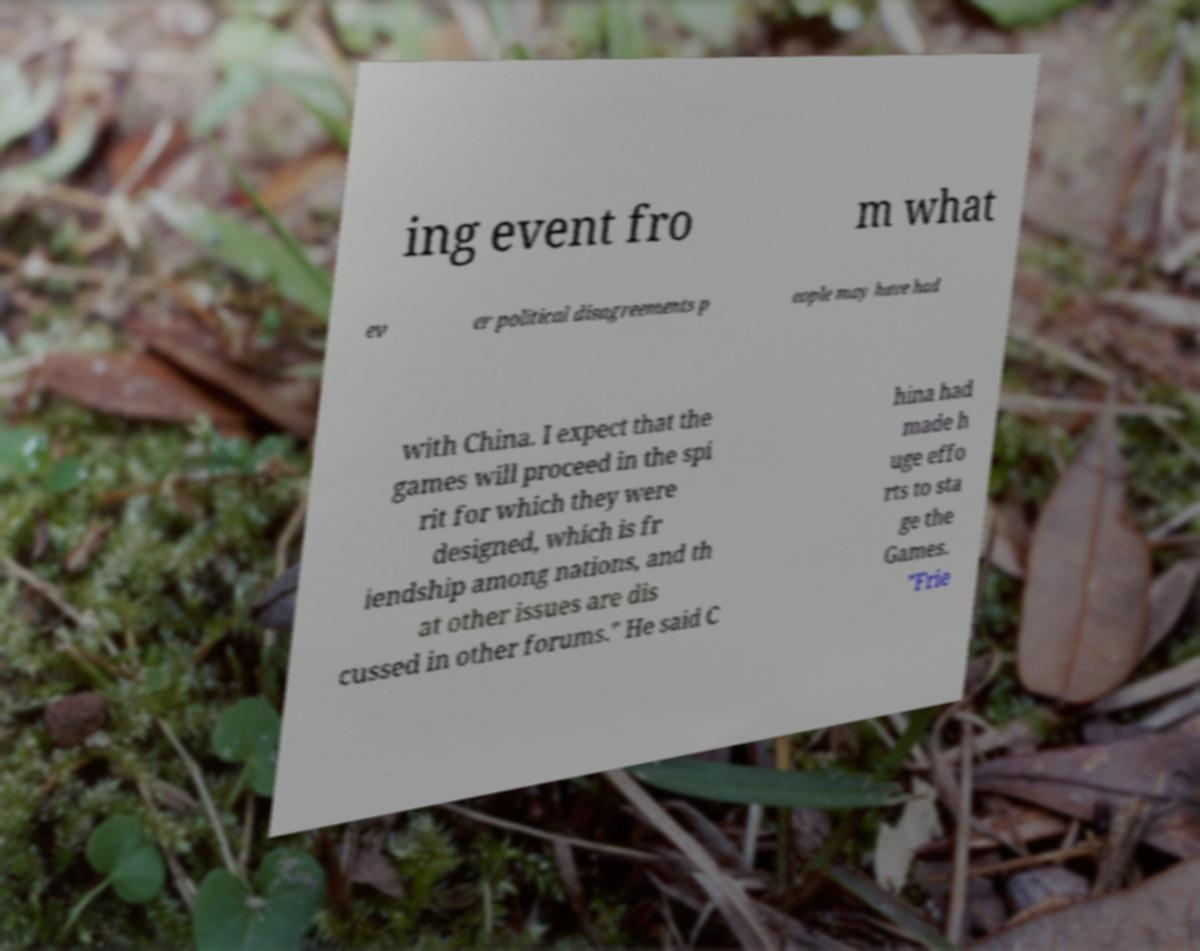Can you accurately transcribe the text from the provided image for me? ing event fro m what ev er political disagreements p eople may have had with China. I expect that the games will proceed in the spi rit for which they were designed, which is fr iendship among nations, and th at other issues are dis cussed in other forums." He said C hina had made h uge effo rts to sta ge the Games. "Frie 